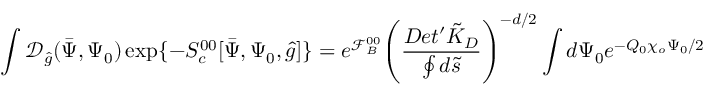<formula> <loc_0><loc_0><loc_500><loc_500>\int { \mathcal { D } _ { \hat { g } } } ( \bar { \Psi } , { \Psi _ { 0 } } ) \exp \{ - { S _ { c } ^ { 0 0 } } [ \bar { \Psi } , { \Psi _ { 0 } } , \hat { g } ] \} = { e ^ { \mathcal { F } _ { B } ^ { 0 0 } } } { { \left ( { \frac { D e t ^ { \prime } { \tilde { K } _ { D } } } { \oint { d } \tilde { s } } } \right ) } ^ { - d / 2 } } \int { d } { \Psi _ { 0 } } { e ^ { - { Q _ { 0 } } { \chi _ { o } } { \Psi _ { 0 } } / 2 } }</formula> 